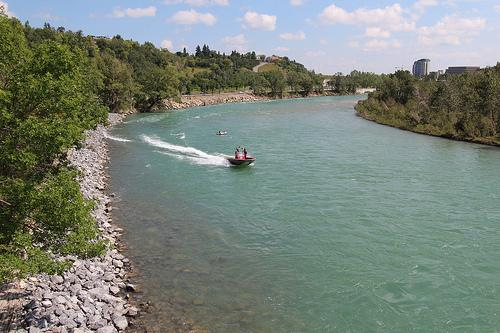What type of boat is in the image, and what is its main color? There is a small speedboat with a red interior in the image. Mention the objects found on the left side of the image. On the left side of the image, there is a large pile of grey rocks, a small grey roadway, green trees, and a rocky shore. Are there people in the image? If so, where and what are they doing? Yes, there are two men standing up in the small speedboat. What is the primary sentiment projected by the image? The primary sentiment projected by the image is a sense of tranquility and natural beauty. What is the image focusing on apart from the main subjects? The image also focuses on the surroundings, such as the riverbank, buildings in the distance, and natural elements like rocks, trees, and clouds. What elements in the image indicate that it's a river scene? The presence of the green river, boat on the water, rocks on the river shore, trees along the riverbank, and the general composition of the image indicate that it's a river scene. Describe the position and appearance of the clouds in the sky. There is a group of white fluffy clouds distributed across the blue sky in various sizes and shapes. List the colors mentioned in the image captions and how they are associated with objects in the scene. White is associated with waves, clouds, and speed boat; grey with rocks, roadway, and skyscraper; blue with sky, water, and clouds; red with boat interior and boat itself; green with trees, river, and water; dark brown with building and rocks. Give a brief description of what can be seen in the distance. In the distance, round shaped skyscrapers, the top of a dark brown building, and a group of dark green trees can be seen. 